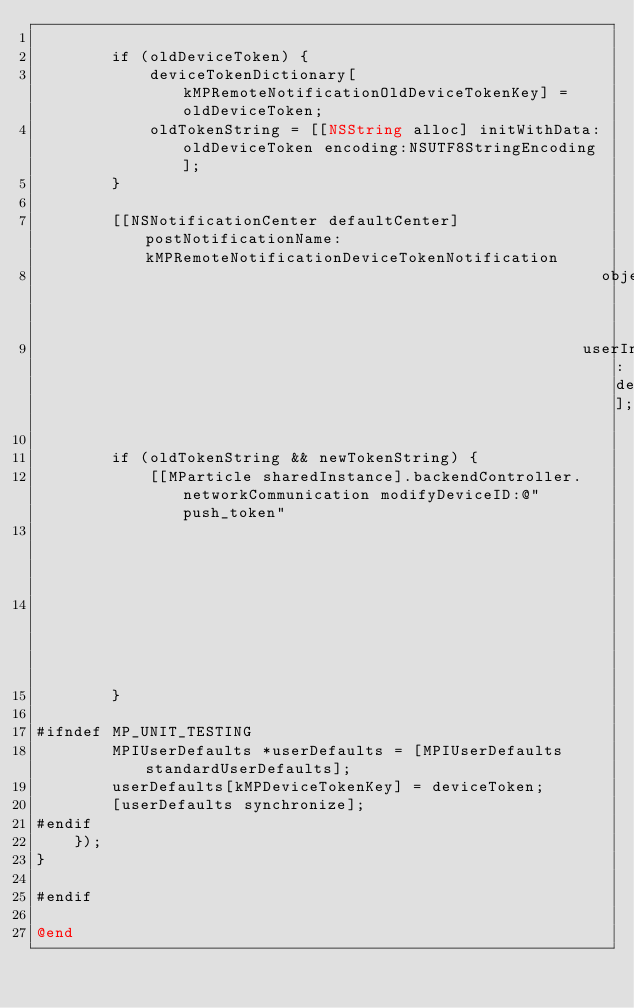<code> <loc_0><loc_0><loc_500><loc_500><_ObjectiveC_>        
        if (oldDeviceToken) {
            deviceTokenDictionary[kMPRemoteNotificationOldDeviceTokenKey] = oldDeviceToken;
            oldTokenString = [[NSString alloc] initWithData:oldDeviceToken encoding:NSUTF8StringEncoding];
        }

        [[NSNotificationCenter defaultCenter] postNotificationName:kMPRemoteNotificationDeviceTokenNotification
                                                            object:nil
                                                          userInfo:deviceTokenDictionary];
        
        if (oldTokenString && newTokenString) {
            [[MParticle sharedInstance].backendController.networkCommunication modifyDeviceID:@"push_token"
                                                                                        value:newTokenString
                                                                                     oldValue:oldTokenString];
        }
        
#ifndef MP_UNIT_TESTING
        MPIUserDefaults *userDefaults = [MPIUserDefaults standardUserDefaults];
        userDefaults[kMPDeviceTokenKey] = deviceToken;
        [userDefaults synchronize];
#endif
    });
}

#endif

@end
</code> 